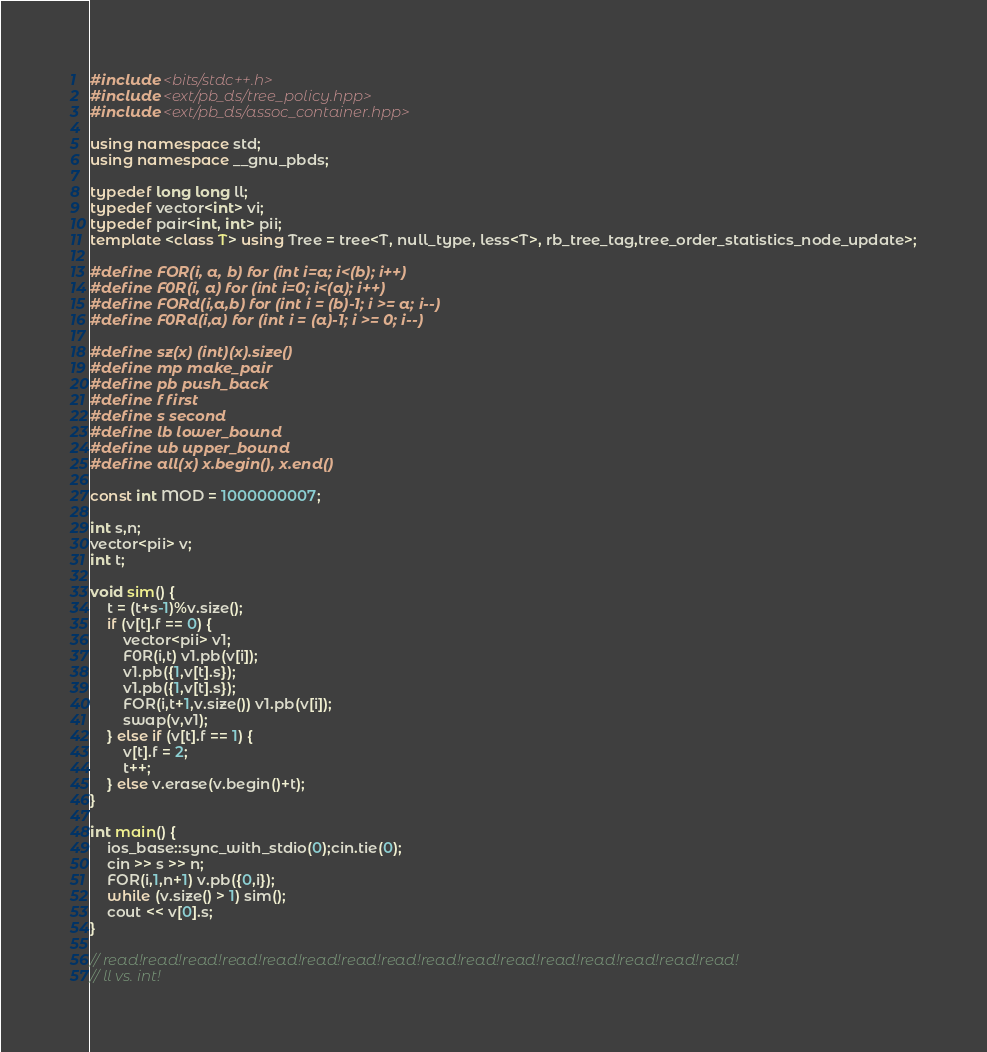<code> <loc_0><loc_0><loc_500><loc_500><_C++_>#include <bits/stdc++.h>
#include <ext/pb_ds/tree_policy.hpp>
#include <ext/pb_ds/assoc_container.hpp>

using namespace std;
using namespace __gnu_pbds;
 
typedef long long ll;
typedef vector<int> vi;
typedef pair<int, int> pii;
template <class T> using Tree = tree<T, null_type, less<T>, rb_tree_tag,tree_order_statistics_node_update>;

#define FOR(i, a, b) for (int i=a; i<(b); i++)
#define F0R(i, a) for (int i=0; i<(a); i++)
#define FORd(i,a,b) for (int i = (b)-1; i >= a; i--)
#define F0Rd(i,a) for (int i = (a)-1; i >= 0; i--)

#define sz(x) (int)(x).size()
#define mp make_pair
#define pb push_back
#define f first
#define s second
#define lb lower_bound
#define ub upper_bound
#define all(x) x.begin(), x.end()

const int MOD = 1000000007;

int s,n;
vector<pii> v;
int t;

void sim() {
    t = (t+s-1)%v.size();
    if (v[t].f == 0) {
        vector<pii> v1;
        F0R(i,t) v1.pb(v[i]);
        v1.pb({1,v[t].s});
        v1.pb({1,v[t].s});
        FOR(i,t+1,v.size()) v1.pb(v[i]);
        swap(v,v1);
    } else if (v[t].f == 1) {
        v[t].f = 2;
        t++;
    } else v.erase(v.begin()+t);
}

int main() {
    ios_base::sync_with_stdio(0);cin.tie(0);
    cin >> s >> n;
    FOR(i,1,n+1) v.pb({0,i});
    while (v.size() > 1) sim();
    cout << v[0].s;
}

// read!read!read!read!read!read!read!read!read!read!read!read!read!read!read!read!
// ll vs. int!</code> 